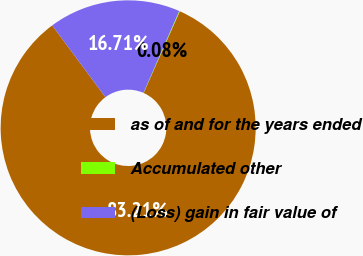<chart> <loc_0><loc_0><loc_500><loc_500><pie_chart><fcel>as of and for the years ended<fcel>Accumulated other<fcel>(Loss) gain in fair value of<nl><fcel>83.21%<fcel>0.08%<fcel>16.71%<nl></chart> 